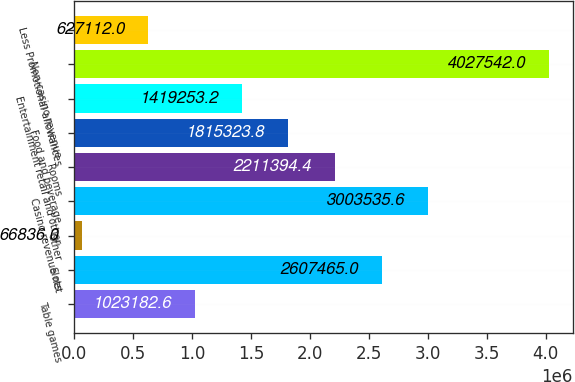<chart> <loc_0><loc_0><loc_500><loc_500><bar_chart><fcel>Table games<fcel>Slots<fcel>Other<fcel>Casino revenue net<fcel>Rooms<fcel>Food and beverage<fcel>Entertainment retail and other<fcel>Non-casino revenue<fcel>Less Promotional allowances<nl><fcel>1.02318e+06<fcel>2.60746e+06<fcel>66836<fcel>3.00354e+06<fcel>2.21139e+06<fcel>1.81532e+06<fcel>1.41925e+06<fcel>4.02754e+06<fcel>627112<nl></chart> 